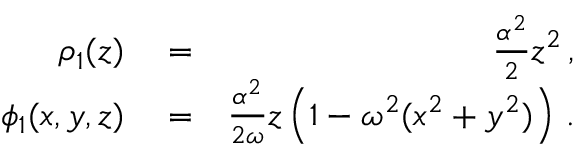Convert formula to latex. <formula><loc_0><loc_0><loc_500><loc_500>\begin{array} { r l r } { \rho _ { 1 } ( z ) } & = } & { \frac { \alpha ^ { 2 } } { 2 } z ^ { 2 } \, , } \\ { \phi _ { 1 } ( x , y , z ) } & = } & { \frac { \alpha ^ { 2 } } { 2 \omega } z \left ( 1 - \omega ^ { 2 } ( x ^ { 2 } + y ^ { 2 } ) \right ) \, . } \end{array}</formula> 